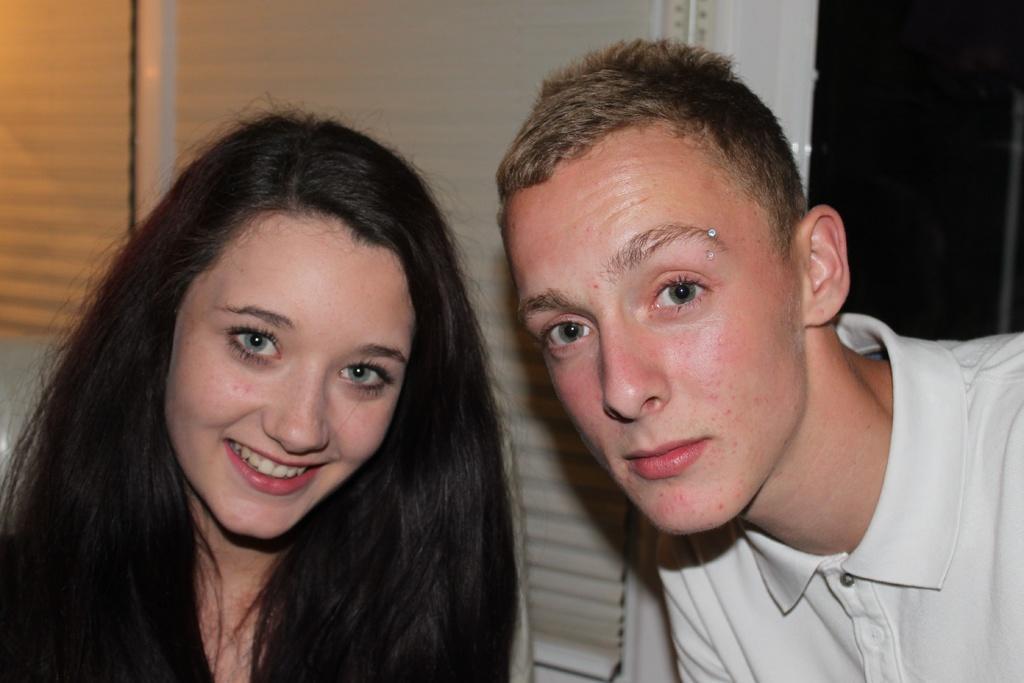Could you give a brief overview of what you see in this image? In this image we can see two persons, behind them, we can see the wall. 